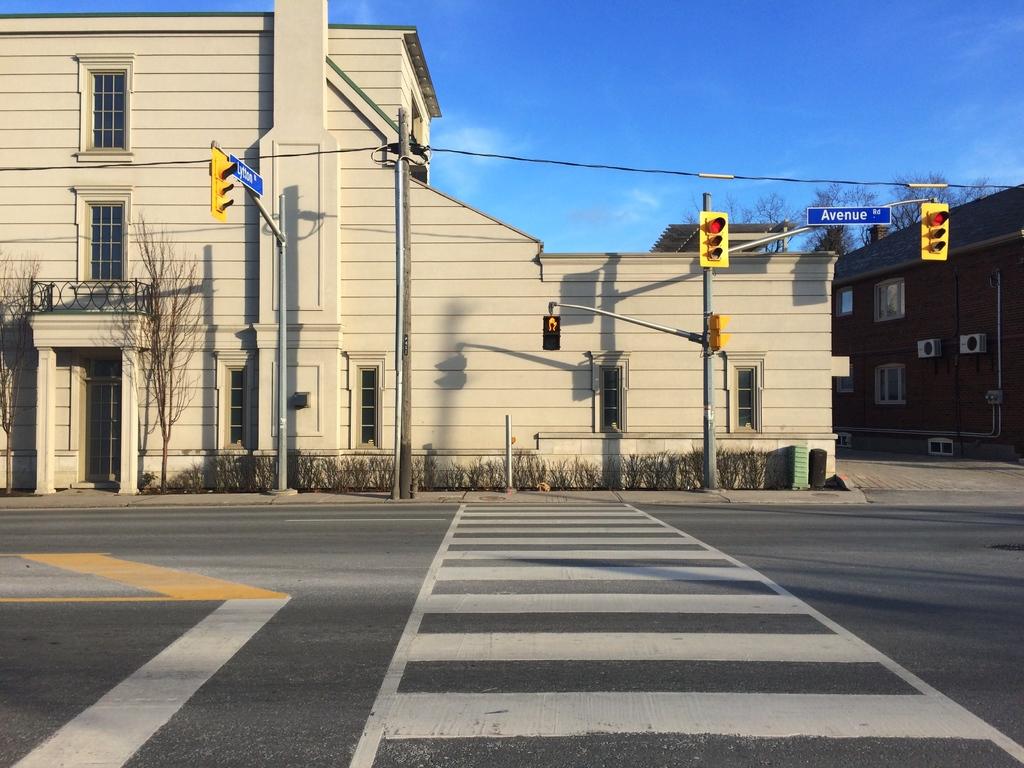What dose the sign above the street say?
Ensure brevity in your answer.  Avenue. What does the sign on the left say?
Your answer should be compact. Unanswerable. 